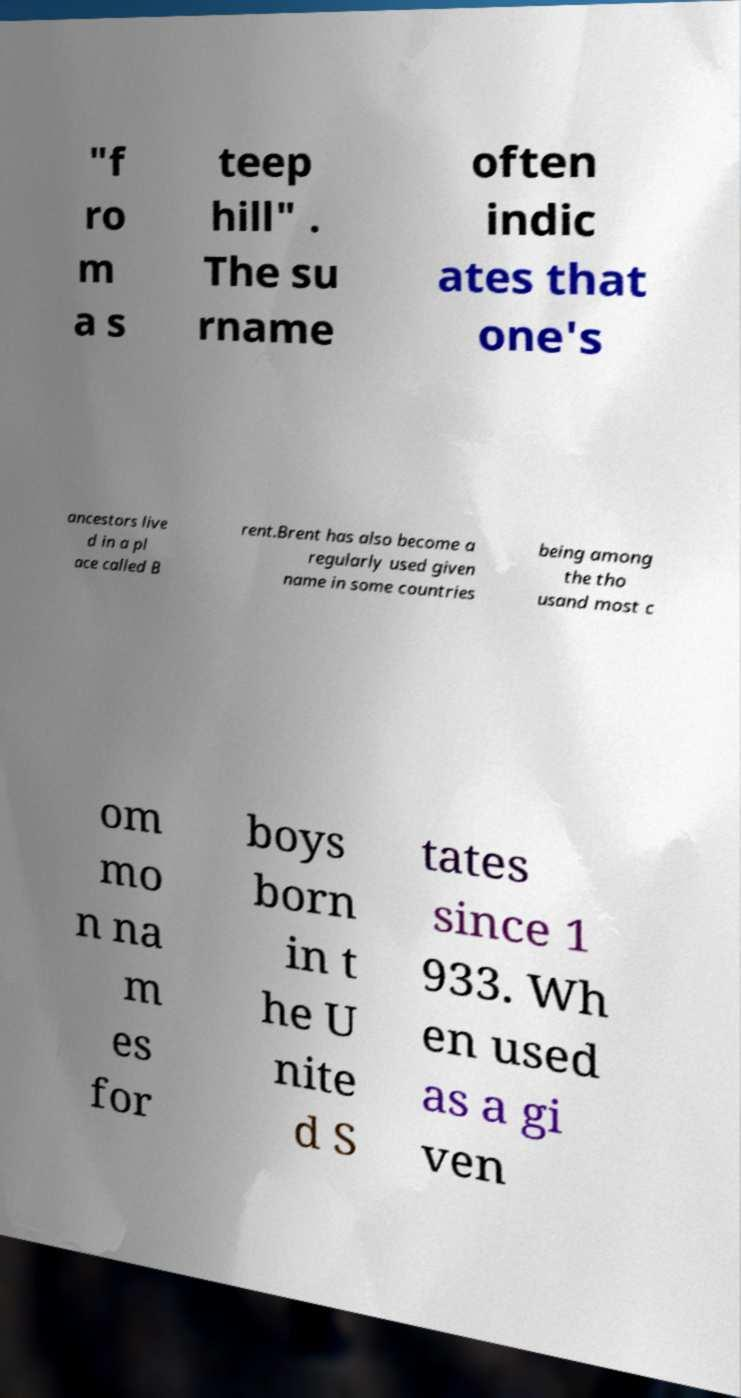Could you extract and type out the text from this image? "f ro m a s teep hill" . The su rname often indic ates that one's ancestors live d in a pl ace called B rent.Brent has also become a regularly used given name in some countries being among the tho usand most c om mo n na m es for boys born in t he U nite d S tates since 1 933. Wh en used as a gi ven 